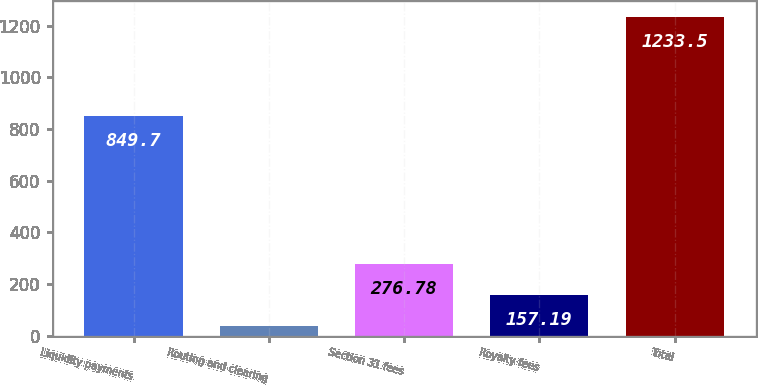Convert chart to OTSL. <chart><loc_0><loc_0><loc_500><loc_500><bar_chart><fcel>Liquidity payments<fcel>Routing and clearing<fcel>Section 31 fees<fcel>Royalty fees<fcel>Total<nl><fcel>849.7<fcel>37.6<fcel>276.78<fcel>157.19<fcel>1233.5<nl></chart> 